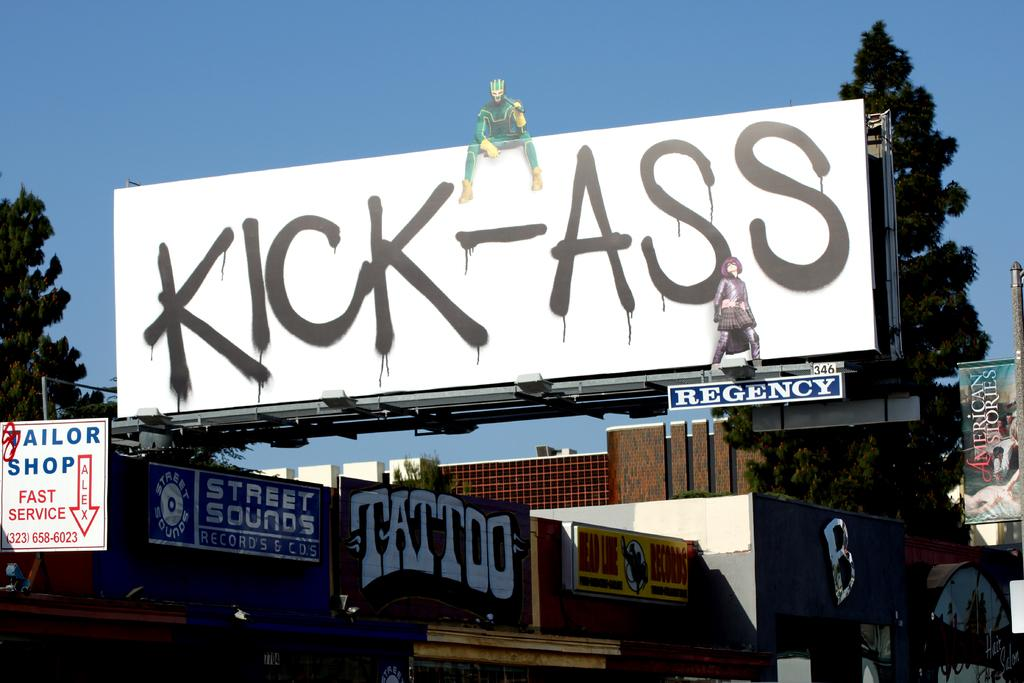<image>
Offer a succinct explanation of the picture presented. a sign with the word kick ass on it 